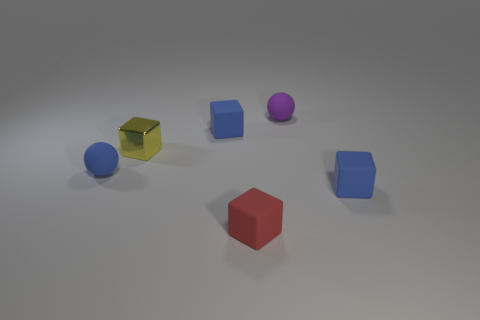Is there any other thing that is the same material as the small yellow thing?
Offer a terse response. No. There is a thing that is both behind the tiny yellow metal thing and on the right side of the small red rubber object; what color is it?
Your answer should be compact. Purple. Is there any other thing of the same color as the small shiny thing?
Your answer should be very brief. No. There is a blue object that is right of the red matte thing to the right of the tiny yellow metallic thing to the left of the small red cube; what shape is it?
Offer a terse response. Cube. There is another tiny object that is the same shape as the small purple matte object; what color is it?
Make the answer very short. Blue. What is the color of the rubber block in front of the blue block to the right of the purple ball?
Keep it short and to the point. Red. What is the size of the other rubber thing that is the same shape as the small purple rubber thing?
Keep it short and to the point. Small. How many tiny yellow things have the same material as the tiny red block?
Provide a succinct answer. 0. How many rubber cubes are in front of the blue rubber cube left of the red cube?
Provide a succinct answer. 2. There is a small yellow metallic object; are there any rubber objects on the left side of it?
Your response must be concise. Yes. 